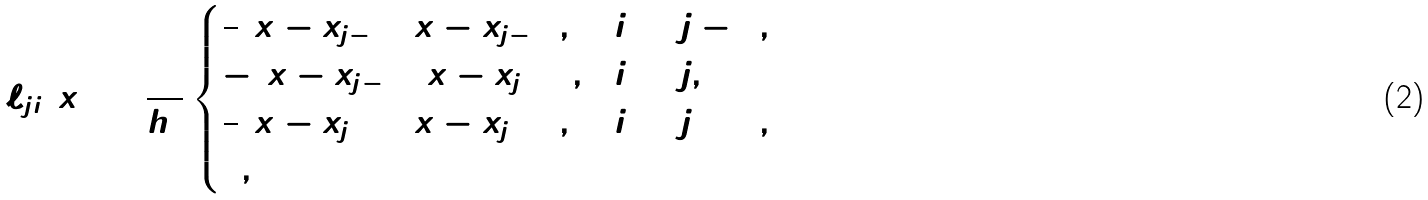Convert formula to latex. <formula><loc_0><loc_0><loc_500><loc_500>\ell _ { j i } ( x ) = \frac { 1 } { h ^ { 2 } } \begin{cases} \frac { 1 } { 2 } ( x - x _ { j - 2 } ) ( x - x _ { j - 1 } ) , & i = j - 1 , \\ - ( x - x _ { j - 1 } ) ( x - x _ { j + 1 } ) , & i = j , \\ \frac { 1 } { 2 } ( x - x _ { j + 1 } ) ( x - x _ { j + 2 } ) , & i = j + 1 , \\ 0 , & \end{cases}</formula> 